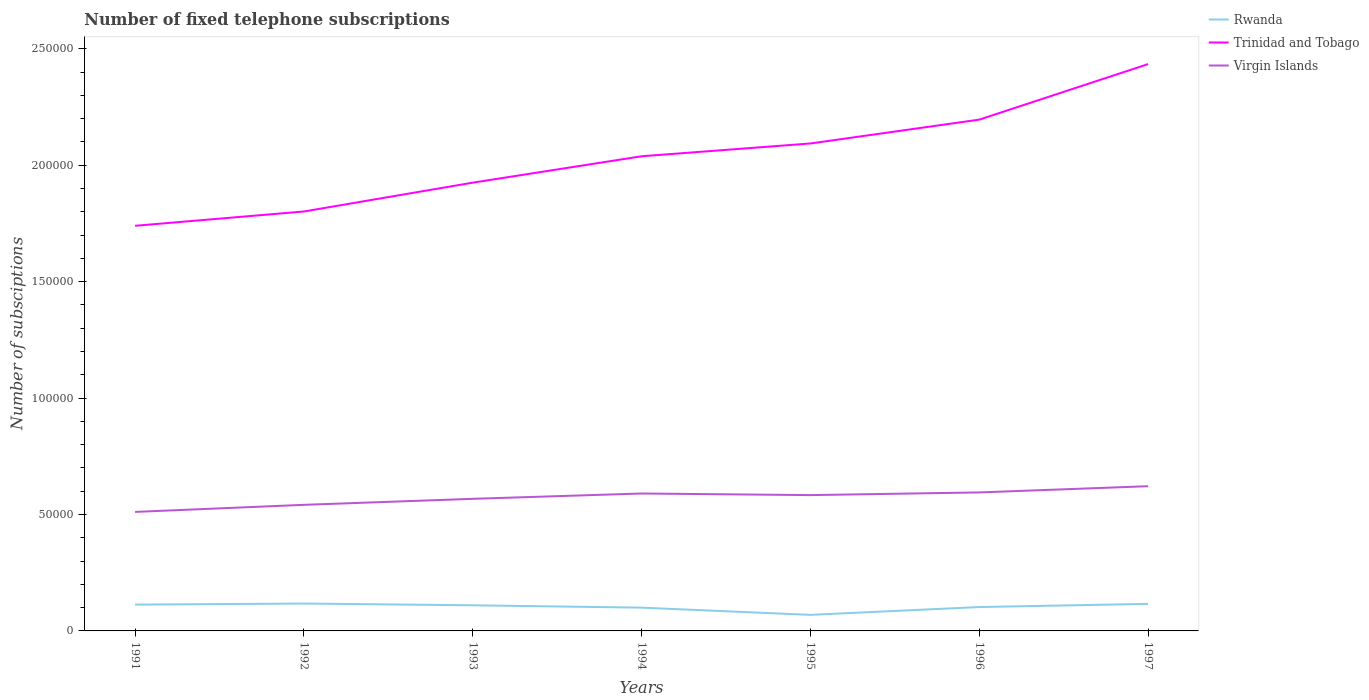How many different coloured lines are there?
Your answer should be very brief. 3. Across all years, what is the maximum number of fixed telephone subscriptions in Rwanda?
Make the answer very short. 6900. In which year was the number of fixed telephone subscriptions in Virgin Islands maximum?
Your answer should be compact. 1991. What is the total number of fixed telephone subscriptions in Virgin Islands in the graph?
Provide a short and direct response. -2291. What is the difference between the highest and the second highest number of fixed telephone subscriptions in Rwanda?
Keep it short and to the point. 4863. How many lines are there?
Your response must be concise. 3. What is the difference between two consecutive major ticks on the Y-axis?
Keep it short and to the point. 5.00e+04. Are the values on the major ticks of Y-axis written in scientific E-notation?
Your response must be concise. No. Where does the legend appear in the graph?
Make the answer very short. Top right. How many legend labels are there?
Provide a short and direct response. 3. What is the title of the graph?
Your response must be concise. Number of fixed telephone subscriptions. Does "France" appear as one of the legend labels in the graph?
Offer a terse response. No. What is the label or title of the Y-axis?
Provide a short and direct response. Number of subsciptions. What is the Number of subsciptions in Rwanda in 1991?
Offer a very short reply. 1.13e+04. What is the Number of subsciptions of Trinidad and Tobago in 1991?
Keep it short and to the point. 1.74e+05. What is the Number of subsciptions of Virgin Islands in 1991?
Ensure brevity in your answer.  5.11e+04. What is the Number of subsciptions in Rwanda in 1992?
Offer a terse response. 1.18e+04. What is the Number of subsciptions of Trinidad and Tobago in 1992?
Offer a very short reply. 1.80e+05. What is the Number of subsciptions in Virgin Islands in 1992?
Provide a short and direct response. 5.41e+04. What is the Number of subsciptions in Rwanda in 1993?
Make the answer very short. 1.10e+04. What is the Number of subsciptions in Trinidad and Tobago in 1993?
Offer a terse response. 1.92e+05. What is the Number of subsciptions of Virgin Islands in 1993?
Provide a succinct answer. 5.67e+04. What is the Number of subsciptions in Rwanda in 1994?
Offer a very short reply. 10000. What is the Number of subsciptions in Trinidad and Tobago in 1994?
Make the answer very short. 2.04e+05. What is the Number of subsciptions of Virgin Islands in 1994?
Make the answer very short. 5.90e+04. What is the Number of subsciptions in Rwanda in 1995?
Keep it short and to the point. 6900. What is the Number of subsciptions in Trinidad and Tobago in 1995?
Your response must be concise. 2.09e+05. What is the Number of subsciptions of Virgin Islands in 1995?
Your response must be concise. 5.83e+04. What is the Number of subsciptions of Rwanda in 1996?
Make the answer very short. 1.03e+04. What is the Number of subsciptions of Trinidad and Tobago in 1996?
Give a very brief answer. 2.20e+05. What is the Number of subsciptions of Virgin Islands in 1996?
Provide a short and direct response. 5.95e+04. What is the Number of subsciptions in Rwanda in 1997?
Your answer should be very brief. 1.16e+04. What is the Number of subsciptions of Trinidad and Tobago in 1997?
Your answer should be compact. 2.43e+05. What is the Number of subsciptions in Virgin Islands in 1997?
Give a very brief answer. 6.21e+04. Across all years, what is the maximum Number of subsciptions in Rwanda?
Offer a terse response. 1.18e+04. Across all years, what is the maximum Number of subsciptions of Trinidad and Tobago?
Make the answer very short. 2.43e+05. Across all years, what is the maximum Number of subsciptions of Virgin Islands?
Keep it short and to the point. 6.21e+04. Across all years, what is the minimum Number of subsciptions of Rwanda?
Offer a terse response. 6900. Across all years, what is the minimum Number of subsciptions of Trinidad and Tobago?
Keep it short and to the point. 1.74e+05. Across all years, what is the minimum Number of subsciptions of Virgin Islands?
Offer a terse response. 5.11e+04. What is the total Number of subsciptions in Rwanda in the graph?
Ensure brevity in your answer.  7.28e+04. What is the total Number of subsciptions in Trinidad and Tobago in the graph?
Offer a terse response. 1.42e+06. What is the total Number of subsciptions of Virgin Islands in the graph?
Offer a terse response. 4.01e+05. What is the difference between the Number of subsciptions of Rwanda in 1991 and that in 1992?
Make the answer very short. -465. What is the difference between the Number of subsciptions of Trinidad and Tobago in 1991 and that in 1992?
Offer a very short reply. -6143. What is the difference between the Number of subsciptions in Virgin Islands in 1991 and that in 1992?
Offer a very short reply. -3038. What is the difference between the Number of subsciptions of Rwanda in 1991 and that in 1993?
Give a very brief answer. 298. What is the difference between the Number of subsciptions of Trinidad and Tobago in 1991 and that in 1993?
Your response must be concise. -1.85e+04. What is the difference between the Number of subsciptions of Virgin Islands in 1991 and that in 1993?
Ensure brevity in your answer.  -5617. What is the difference between the Number of subsciptions in Rwanda in 1991 and that in 1994?
Your answer should be compact. 1298. What is the difference between the Number of subsciptions of Trinidad and Tobago in 1991 and that in 1994?
Give a very brief answer. -2.99e+04. What is the difference between the Number of subsciptions of Virgin Islands in 1991 and that in 1994?
Your answer should be compact. -7908. What is the difference between the Number of subsciptions of Rwanda in 1991 and that in 1995?
Keep it short and to the point. 4398. What is the difference between the Number of subsciptions in Trinidad and Tobago in 1991 and that in 1995?
Offer a terse response. -3.53e+04. What is the difference between the Number of subsciptions in Virgin Islands in 1991 and that in 1995?
Offer a very short reply. -7215. What is the difference between the Number of subsciptions in Rwanda in 1991 and that in 1996?
Provide a succinct answer. 1044. What is the difference between the Number of subsciptions in Trinidad and Tobago in 1991 and that in 1996?
Provide a short and direct response. -4.56e+04. What is the difference between the Number of subsciptions of Virgin Islands in 1991 and that in 1996?
Your response must be concise. -8366. What is the difference between the Number of subsciptions of Rwanda in 1991 and that in 1997?
Your response must be concise. -323. What is the difference between the Number of subsciptions of Trinidad and Tobago in 1991 and that in 1997?
Your answer should be compact. -6.94e+04. What is the difference between the Number of subsciptions of Virgin Islands in 1991 and that in 1997?
Offer a terse response. -1.10e+04. What is the difference between the Number of subsciptions in Rwanda in 1992 and that in 1993?
Provide a succinct answer. 763. What is the difference between the Number of subsciptions of Trinidad and Tobago in 1992 and that in 1993?
Keep it short and to the point. -1.24e+04. What is the difference between the Number of subsciptions of Virgin Islands in 1992 and that in 1993?
Your answer should be compact. -2579. What is the difference between the Number of subsciptions of Rwanda in 1992 and that in 1994?
Provide a short and direct response. 1763. What is the difference between the Number of subsciptions in Trinidad and Tobago in 1992 and that in 1994?
Provide a succinct answer. -2.37e+04. What is the difference between the Number of subsciptions in Virgin Islands in 1992 and that in 1994?
Your answer should be very brief. -4870. What is the difference between the Number of subsciptions of Rwanda in 1992 and that in 1995?
Your response must be concise. 4863. What is the difference between the Number of subsciptions of Trinidad and Tobago in 1992 and that in 1995?
Make the answer very short. -2.92e+04. What is the difference between the Number of subsciptions of Virgin Islands in 1992 and that in 1995?
Give a very brief answer. -4177. What is the difference between the Number of subsciptions of Rwanda in 1992 and that in 1996?
Provide a succinct answer. 1509. What is the difference between the Number of subsciptions in Trinidad and Tobago in 1992 and that in 1996?
Your answer should be very brief. -3.94e+04. What is the difference between the Number of subsciptions in Virgin Islands in 1992 and that in 1996?
Your answer should be very brief. -5328. What is the difference between the Number of subsciptions of Rwanda in 1992 and that in 1997?
Ensure brevity in your answer.  142. What is the difference between the Number of subsciptions in Trinidad and Tobago in 1992 and that in 1997?
Your answer should be compact. -6.33e+04. What is the difference between the Number of subsciptions of Virgin Islands in 1992 and that in 1997?
Make the answer very short. -7998. What is the difference between the Number of subsciptions of Rwanda in 1993 and that in 1994?
Provide a succinct answer. 1000. What is the difference between the Number of subsciptions in Trinidad and Tobago in 1993 and that in 1994?
Give a very brief answer. -1.13e+04. What is the difference between the Number of subsciptions in Virgin Islands in 1993 and that in 1994?
Offer a very short reply. -2291. What is the difference between the Number of subsciptions of Rwanda in 1993 and that in 1995?
Your answer should be compact. 4100. What is the difference between the Number of subsciptions of Trinidad and Tobago in 1993 and that in 1995?
Offer a very short reply. -1.68e+04. What is the difference between the Number of subsciptions of Virgin Islands in 1993 and that in 1995?
Provide a succinct answer. -1598. What is the difference between the Number of subsciptions in Rwanda in 1993 and that in 1996?
Provide a succinct answer. 746. What is the difference between the Number of subsciptions in Trinidad and Tobago in 1993 and that in 1996?
Your response must be concise. -2.71e+04. What is the difference between the Number of subsciptions in Virgin Islands in 1993 and that in 1996?
Keep it short and to the point. -2749. What is the difference between the Number of subsciptions of Rwanda in 1993 and that in 1997?
Your answer should be compact. -621. What is the difference between the Number of subsciptions of Trinidad and Tobago in 1993 and that in 1997?
Make the answer very short. -5.09e+04. What is the difference between the Number of subsciptions in Virgin Islands in 1993 and that in 1997?
Provide a short and direct response. -5419. What is the difference between the Number of subsciptions in Rwanda in 1994 and that in 1995?
Ensure brevity in your answer.  3100. What is the difference between the Number of subsciptions of Trinidad and Tobago in 1994 and that in 1995?
Offer a terse response. -5493. What is the difference between the Number of subsciptions of Virgin Islands in 1994 and that in 1995?
Offer a terse response. 693. What is the difference between the Number of subsciptions in Rwanda in 1994 and that in 1996?
Your answer should be compact. -254. What is the difference between the Number of subsciptions of Trinidad and Tobago in 1994 and that in 1996?
Give a very brief answer. -1.57e+04. What is the difference between the Number of subsciptions of Virgin Islands in 1994 and that in 1996?
Offer a terse response. -458. What is the difference between the Number of subsciptions in Rwanda in 1994 and that in 1997?
Give a very brief answer. -1621. What is the difference between the Number of subsciptions of Trinidad and Tobago in 1994 and that in 1997?
Ensure brevity in your answer.  -3.96e+04. What is the difference between the Number of subsciptions of Virgin Islands in 1994 and that in 1997?
Ensure brevity in your answer.  -3128. What is the difference between the Number of subsciptions in Rwanda in 1995 and that in 1996?
Keep it short and to the point. -3354. What is the difference between the Number of subsciptions in Trinidad and Tobago in 1995 and that in 1996?
Give a very brief answer. -1.02e+04. What is the difference between the Number of subsciptions of Virgin Islands in 1995 and that in 1996?
Offer a terse response. -1151. What is the difference between the Number of subsciptions of Rwanda in 1995 and that in 1997?
Offer a very short reply. -4721. What is the difference between the Number of subsciptions in Trinidad and Tobago in 1995 and that in 1997?
Your answer should be compact. -3.41e+04. What is the difference between the Number of subsciptions of Virgin Islands in 1995 and that in 1997?
Your answer should be very brief. -3821. What is the difference between the Number of subsciptions in Rwanda in 1996 and that in 1997?
Your answer should be very brief. -1367. What is the difference between the Number of subsciptions in Trinidad and Tobago in 1996 and that in 1997?
Make the answer very short. -2.38e+04. What is the difference between the Number of subsciptions of Virgin Islands in 1996 and that in 1997?
Offer a very short reply. -2670. What is the difference between the Number of subsciptions of Rwanda in 1991 and the Number of subsciptions of Trinidad and Tobago in 1992?
Provide a succinct answer. -1.69e+05. What is the difference between the Number of subsciptions in Rwanda in 1991 and the Number of subsciptions in Virgin Islands in 1992?
Keep it short and to the point. -4.28e+04. What is the difference between the Number of subsciptions of Trinidad and Tobago in 1991 and the Number of subsciptions of Virgin Islands in 1992?
Keep it short and to the point. 1.20e+05. What is the difference between the Number of subsciptions in Rwanda in 1991 and the Number of subsciptions in Trinidad and Tobago in 1993?
Provide a short and direct response. -1.81e+05. What is the difference between the Number of subsciptions in Rwanda in 1991 and the Number of subsciptions in Virgin Islands in 1993?
Give a very brief answer. -4.54e+04. What is the difference between the Number of subsciptions in Trinidad and Tobago in 1991 and the Number of subsciptions in Virgin Islands in 1993?
Provide a short and direct response. 1.17e+05. What is the difference between the Number of subsciptions of Rwanda in 1991 and the Number of subsciptions of Trinidad and Tobago in 1994?
Ensure brevity in your answer.  -1.93e+05. What is the difference between the Number of subsciptions of Rwanda in 1991 and the Number of subsciptions of Virgin Islands in 1994?
Provide a short and direct response. -4.77e+04. What is the difference between the Number of subsciptions in Trinidad and Tobago in 1991 and the Number of subsciptions in Virgin Islands in 1994?
Offer a very short reply. 1.15e+05. What is the difference between the Number of subsciptions in Rwanda in 1991 and the Number of subsciptions in Trinidad and Tobago in 1995?
Your answer should be very brief. -1.98e+05. What is the difference between the Number of subsciptions in Rwanda in 1991 and the Number of subsciptions in Virgin Islands in 1995?
Give a very brief answer. -4.70e+04. What is the difference between the Number of subsciptions of Trinidad and Tobago in 1991 and the Number of subsciptions of Virgin Islands in 1995?
Provide a succinct answer. 1.16e+05. What is the difference between the Number of subsciptions in Rwanda in 1991 and the Number of subsciptions in Trinidad and Tobago in 1996?
Your answer should be compact. -2.08e+05. What is the difference between the Number of subsciptions in Rwanda in 1991 and the Number of subsciptions in Virgin Islands in 1996?
Your answer should be compact. -4.82e+04. What is the difference between the Number of subsciptions of Trinidad and Tobago in 1991 and the Number of subsciptions of Virgin Islands in 1996?
Keep it short and to the point. 1.14e+05. What is the difference between the Number of subsciptions in Rwanda in 1991 and the Number of subsciptions in Trinidad and Tobago in 1997?
Ensure brevity in your answer.  -2.32e+05. What is the difference between the Number of subsciptions of Rwanda in 1991 and the Number of subsciptions of Virgin Islands in 1997?
Provide a succinct answer. -5.08e+04. What is the difference between the Number of subsciptions of Trinidad and Tobago in 1991 and the Number of subsciptions of Virgin Islands in 1997?
Your answer should be very brief. 1.12e+05. What is the difference between the Number of subsciptions in Rwanda in 1992 and the Number of subsciptions in Trinidad and Tobago in 1993?
Make the answer very short. -1.81e+05. What is the difference between the Number of subsciptions of Rwanda in 1992 and the Number of subsciptions of Virgin Islands in 1993?
Provide a short and direct response. -4.50e+04. What is the difference between the Number of subsciptions of Trinidad and Tobago in 1992 and the Number of subsciptions of Virgin Islands in 1993?
Provide a short and direct response. 1.23e+05. What is the difference between the Number of subsciptions of Rwanda in 1992 and the Number of subsciptions of Trinidad and Tobago in 1994?
Keep it short and to the point. -1.92e+05. What is the difference between the Number of subsciptions in Rwanda in 1992 and the Number of subsciptions in Virgin Islands in 1994?
Offer a terse response. -4.72e+04. What is the difference between the Number of subsciptions in Trinidad and Tobago in 1992 and the Number of subsciptions in Virgin Islands in 1994?
Your answer should be compact. 1.21e+05. What is the difference between the Number of subsciptions in Rwanda in 1992 and the Number of subsciptions in Trinidad and Tobago in 1995?
Give a very brief answer. -1.98e+05. What is the difference between the Number of subsciptions of Rwanda in 1992 and the Number of subsciptions of Virgin Islands in 1995?
Offer a terse response. -4.66e+04. What is the difference between the Number of subsciptions in Trinidad and Tobago in 1992 and the Number of subsciptions in Virgin Islands in 1995?
Offer a terse response. 1.22e+05. What is the difference between the Number of subsciptions in Rwanda in 1992 and the Number of subsciptions in Trinidad and Tobago in 1996?
Provide a short and direct response. -2.08e+05. What is the difference between the Number of subsciptions of Rwanda in 1992 and the Number of subsciptions of Virgin Islands in 1996?
Offer a very short reply. -4.77e+04. What is the difference between the Number of subsciptions in Trinidad and Tobago in 1992 and the Number of subsciptions in Virgin Islands in 1996?
Ensure brevity in your answer.  1.21e+05. What is the difference between the Number of subsciptions of Rwanda in 1992 and the Number of subsciptions of Trinidad and Tobago in 1997?
Your response must be concise. -2.32e+05. What is the difference between the Number of subsciptions in Rwanda in 1992 and the Number of subsciptions in Virgin Islands in 1997?
Keep it short and to the point. -5.04e+04. What is the difference between the Number of subsciptions in Trinidad and Tobago in 1992 and the Number of subsciptions in Virgin Islands in 1997?
Provide a short and direct response. 1.18e+05. What is the difference between the Number of subsciptions of Rwanda in 1993 and the Number of subsciptions of Trinidad and Tobago in 1994?
Provide a succinct answer. -1.93e+05. What is the difference between the Number of subsciptions in Rwanda in 1993 and the Number of subsciptions in Virgin Islands in 1994?
Offer a very short reply. -4.80e+04. What is the difference between the Number of subsciptions in Trinidad and Tobago in 1993 and the Number of subsciptions in Virgin Islands in 1994?
Ensure brevity in your answer.  1.33e+05. What is the difference between the Number of subsciptions of Rwanda in 1993 and the Number of subsciptions of Trinidad and Tobago in 1995?
Keep it short and to the point. -1.98e+05. What is the difference between the Number of subsciptions of Rwanda in 1993 and the Number of subsciptions of Virgin Islands in 1995?
Your response must be concise. -4.73e+04. What is the difference between the Number of subsciptions in Trinidad and Tobago in 1993 and the Number of subsciptions in Virgin Islands in 1995?
Make the answer very short. 1.34e+05. What is the difference between the Number of subsciptions of Rwanda in 1993 and the Number of subsciptions of Trinidad and Tobago in 1996?
Your answer should be compact. -2.09e+05. What is the difference between the Number of subsciptions of Rwanda in 1993 and the Number of subsciptions of Virgin Islands in 1996?
Provide a succinct answer. -4.85e+04. What is the difference between the Number of subsciptions in Trinidad and Tobago in 1993 and the Number of subsciptions in Virgin Islands in 1996?
Ensure brevity in your answer.  1.33e+05. What is the difference between the Number of subsciptions in Rwanda in 1993 and the Number of subsciptions in Trinidad and Tobago in 1997?
Your answer should be very brief. -2.32e+05. What is the difference between the Number of subsciptions in Rwanda in 1993 and the Number of subsciptions in Virgin Islands in 1997?
Keep it short and to the point. -5.11e+04. What is the difference between the Number of subsciptions in Trinidad and Tobago in 1993 and the Number of subsciptions in Virgin Islands in 1997?
Ensure brevity in your answer.  1.30e+05. What is the difference between the Number of subsciptions in Rwanda in 1994 and the Number of subsciptions in Trinidad and Tobago in 1995?
Offer a very short reply. -1.99e+05. What is the difference between the Number of subsciptions of Rwanda in 1994 and the Number of subsciptions of Virgin Islands in 1995?
Make the answer very short. -4.83e+04. What is the difference between the Number of subsciptions in Trinidad and Tobago in 1994 and the Number of subsciptions in Virgin Islands in 1995?
Provide a short and direct response. 1.45e+05. What is the difference between the Number of subsciptions of Rwanda in 1994 and the Number of subsciptions of Trinidad and Tobago in 1996?
Your response must be concise. -2.10e+05. What is the difference between the Number of subsciptions of Rwanda in 1994 and the Number of subsciptions of Virgin Islands in 1996?
Offer a terse response. -4.95e+04. What is the difference between the Number of subsciptions of Trinidad and Tobago in 1994 and the Number of subsciptions of Virgin Islands in 1996?
Offer a very short reply. 1.44e+05. What is the difference between the Number of subsciptions in Rwanda in 1994 and the Number of subsciptions in Trinidad and Tobago in 1997?
Your answer should be compact. -2.33e+05. What is the difference between the Number of subsciptions in Rwanda in 1994 and the Number of subsciptions in Virgin Islands in 1997?
Make the answer very short. -5.21e+04. What is the difference between the Number of subsciptions of Trinidad and Tobago in 1994 and the Number of subsciptions of Virgin Islands in 1997?
Your response must be concise. 1.42e+05. What is the difference between the Number of subsciptions of Rwanda in 1995 and the Number of subsciptions of Trinidad and Tobago in 1996?
Keep it short and to the point. -2.13e+05. What is the difference between the Number of subsciptions of Rwanda in 1995 and the Number of subsciptions of Virgin Islands in 1996?
Ensure brevity in your answer.  -5.26e+04. What is the difference between the Number of subsciptions of Trinidad and Tobago in 1995 and the Number of subsciptions of Virgin Islands in 1996?
Give a very brief answer. 1.50e+05. What is the difference between the Number of subsciptions in Rwanda in 1995 and the Number of subsciptions in Trinidad and Tobago in 1997?
Offer a very short reply. -2.36e+05. What is the difference between the Number of subsciptions in Rwanda in 1995 and the Number of subsciptions in Virgin Islands in 1997?
Ensure brevity in your answer.  -5.52e+04. What is the difference between the Number of subsciptions of Trinidad and Tobago in 1995 and the Number of subsciptions of Virgin Islands in 1997?
Your answer should be very brief. 1.47e+05. What is the difference between the Number of subsciptions in Rwanda in 1996 and the Number of subsciptions in Trinidad and Tobago in 1997?
Your answer should be very brief. -2.33e+05. What is the difference between the Number of subsciptions of Rwanda in 1996 and the Number of subsciptions of Virgin Islands in 1997?
Make the answer very short. -5.19e+04. What is the difference between the Number of subsciptions in Trinidad and Tobago in 1996 and the Number of subsciptions in Virgin Islands in 1997?
Provide a short and direct response. 1.57e+05. What is the average Number of subsciptions in Rwanda per year?
Offer a terse response. 1.04e+04. What is the average Number of subsciptions of Trinidad and Tobago per year?
Your answer should be very brief. 2.03e+05. What is the average Number of subsciptions of Virgin Islands per year?
Your answer should be compact. 5.73e+04. In the year 1991, what is the difference between the Number of subsciptions in Rwanda and Number of subsciptions in Trinidad and Tobago?
Make the answer very short. -1.63e+05. In the year 1991, what is the difference between the Number of subsciptions of Rwanda and Number of subsciptions of Virgin Islands?
Provide a succinct answer. -3.98e+04. In the year 1991, what is the difference between the Number of subsciptions of Trinidad and Tobago and Number of subsciptions of Virgin Islands?
Your response must be concise. 1.23e+05. In the year 1992, what is the difference between the Number of subsciptions in Rwanda and Number of subsciptions in Trinidad and Tobago?
Offer a terse response. -1.68e+05. In the year 1992, what is the difference between the Number of subsciptions in Rwanda and Number of subsciptions in Virgin Islands?
Offer a very short reply. -4.24e+04. In the year 1992, what is the difference between the Number of subsciptions in Trinidad and Tobago and Number of subsciptions in Virgin Islands?
Your answer should be compact. 1.26e+05. In the year 1993, what is the difference between the Number of subsciptions of Rwanda and Number of subsciptions of Trinidad and Tobago?
Give a very brief answer. -1.81e+05. In the year 1993, what is the difference between the Number of subsciptions of Rwanda and Number of subsciptions of Virgin Islands?
Provide a succinct answer. -4.57e+04. In the year 1993, what is the difference between the Number of subsciptions in Trinidad and Tobago and Number of subsciptions in Virgin Islands?
Keep it short and to the point. 1.36e+05. In the year 1994, what is the difference between the Number of subsciptions in Rwanda and Number of subsciptions in Trinidad and Tobago?
Make the answer very short. -1.94e+05. In the year 1994, what is the difference between the Number of subsciptions of Rwanda and Number of subsciptions of Virgin Islands?
Offer a very short reply. -4.90e+04. In the year 1994, what is the difference between the Number of subsciptions in Trinidad and Tobago and Number of subsciptions in Virgin Islands?
Provide a short and direct response. 1.45e+05. In the year 1995, what is the difference between the Number of subsciptions in Rwanda and Number of subsciptions in Trinidad and Tobago?
Offer a terse response. -2.02e+05. In the year 1995, what is the difference between the Number of subsciptions in Rwanda and Number of subsciptions in Virgin Islands?
Provide a short and direct response. -5.14e+04. In the year 1995, what is the difference between the Number of subsciptions in Trinidad and Tobago and Number of subsciptions in Virgin Islands?
Your answer should be very brief. 1.51e+05. In the year 1996, what is the difference between the Number of subsciptions of Rwanda and Number of subsciptions of Trinidad and Tobago?
Provide a short and direct response. -2.09e+05. In the year 1996, what is the difference between the Number of subsciptions of Rwanda and Number of subsciptions of Virgin Islands?
Offer a terse response. -4.92e+04. In the year 1996, what is the difference between the Number of subsciptions of Trinidad and Tobago and Number of subsciptions of Virgin Islands?
Provide a succinct answer. 1.60e+05. In the year 1997, what is the difference between the Number of subsciptions of Rwanda and Number of subsciptions of Trinidad and Tobago?
Keep it short and to the point. -2.32e+05. In the year 1997, what is the difference between the Number of subsciptions of Rwanda and Number of subsciptions of Virgin Islands?
Offer a very short reply. -5.05e+04. In the year 1997, what is the difference between the Number of subsciptions of Trinidad and Tobago and Number of subsciptions of Virgin Islands?
Provide a succinct answer. 1.81e+05. What is the ratio of the Number of subsciptions of Rwanda in 1991 to that in 1992?
Ensure brevity in your answer.  0.96. What is the ratio of the Number of subsciptions in Trinidad and Tobago in 1991 to that in 1992?
Provide a short and direct response. 0.97. What is the ratio of the Number of subsciptions of Virgin Islands in 1991 to that in 1992?
Offer a very short reply. 0.94. What is the ratio of the Number of subsciptions of Rwanda in 1991 to that in 1993?
Give a very brief answer. 1.03. What is the ratio of the Number of subsciptions in Trinidad and Tobago in 1991 to that in 1993?
Your answer should be very brief. 0.9. What is the ratio of the Number of subsciptions of Virgin Islands in 1991 to that in 1993?
Provide a succinct answer. 0.9. What is the ratio of the Number of subsciptions of Rwanda in 1991 to that in 1994?
Provide a short and direct response. 1.13. What is the ratio of the Number of subsciptions in Trinidad and Tobago in 1991 to that in 1994?
Keep it short and to the point. 0.85. What is the ratio of the Number of subsciptions in Virgin Islands in 1991 to that in 1994?
Your answer should be compact. 0.87. What is the ratio of the Number of subsciptions in Rwanda in 1991 to that in 1995?
Provide a succinct answer. 1.64. What is the ratio of the Number of subsciptions in Trinidad and Tobago in 1991 to that in 1995?
Your response must be concise. 0.83. What is the ratio of the Number of subsciptions of Virgin Islands in 1991 to that in 1995?
Your response must be concise. 0.88. What is the ratio of the Number of subsciptions in Rwanda in 1991 to that in 1996?
Keep it short and to the point. 1.1. What is the ratio of the Number of subsciptions in Trinidad and Tobago in 1991 to that in 1996?
Your answer should be compact. 0.79. What is the ratio of the Number of subsciptions in Virgin Islands in 1991 to that in 1996?
Your response must be concise. 0.86. What is the ratio of the Number of subsciptions of Rwanda in 1991 to that in 1997?
Your answer should be compact. 0.97. What is the ratio of the Number of subsciptions of Trinidad and Tobago in 1991 to that in 1997?
Provide a short and direct response. 0.71. What is the ratio of the Number of subsciptions of Virgin Islands in 1991 to that in 1997?
Provide a short and direct response. 0.82. What is the ratio of the Number of subsciptions in Rwanda in 1992 to that in 1993?
Your answer should be very brief. 1.07. What is the ratio of the Number of subsciptions of Trinidad and Tobago in 1992 to that in 1993?
Offer a terse response. 0.94. What is the ratio of the Number of subsciptions of Virgin Islands in 1992 to that in 1993?
Keep it short and to the point. 0.95. What is the ratio of the Number of subsciptions of Rwanda in 1992 to that in 1994?
Make the answer very short. 1.18. What is the ratio of the Number of subsciptions of Trinidad and Tobago in 1992 to that in 1994?
Provide a succinct answer. 0.88. What is the ratio of the Number of subsciptions in Virgin Islands in 1992 to that in 1994?
Offer a very short reply. 0.92. What is the ratio of the Number of subsciptions of Rwanda in 1992 to that in 1995?
Ensure brevity in your answer.  1.7. What is the ratio of the Number of subsciptions in Trinidad and Tobago in 1992 to that in 1995?
Your answer should be compact. 0.86. What is the ratio of the Number of subsciptions of Virgin Islands in 1992 to that in 1995?
Your response must be concise. 0.93. What is the ratio of the Number of subsciptions of Rwanda in 1992 to that in 1996?
Offer a terse response. 1.15. What is the ratio of the Number of subsciptions of Trinidad and Tobago in 1992 to that in 1996?
Give a very brief answer. 0.82. What is the ratio of the Number of subsciptions in Virgin Islands in 1992 to that in 1996?
Your answer should be very brief. 0.91. What is the ratio of the Number of subsciptions of Rwanda in 1992 to that in 1997?
Provide a short and direct response. 1.01. What is the ratio of the Number of subsciptions in Trinidad and Tobago in 1992 to that in 1997?
Your answer should be very brief. 0.74. What is the ratio of the Number of subsciptions in Virgin Islands in 1992 to that in 1997?
Keep it short and to the point. 0.87. What is the ratio of the Number of subsciptions of Virgin Islands in 1993 to that in 1994?
Give a very brief answer. 0.96. What is the ratio of the Number of subsciptions of Rwanda in 1993 to that in 1995?
Your answer should be compact. 1.59. What is the ratio of the Number of subsciptions in Trinidad and Tobago in 1993 to that in 1995?
Offer a very short reply. 0.92. What is the ratio of the Number of subsciptions in Virgin Islands in 1993 to that in 1995?
Make the answer very short. 0.97. What is the ratio of the Number of subsciptions of Rwanda in 1993 to that in 1996?
Offer a very short reply. 1.07. What is the ratio of the Number of subsciptions of Trinidad and Tobago in 1993 to that in 1996?
Give a very brief answer. 0.88. What is the ratio of the Number of subsciptions in Virgin Islands in 1993 to that in 1996?
Offer a terse response. 0.95. What is the ratio of the Number of subsciptions of Rwanda in 1993 to that in 1997?
Make the answer very short. 0.95. What is the ratio of the Number of subsciptions of Trinidad and Tobago in 1993 to that in 1997?
Your answer should be compact. 0.79. What is the ratio of the Number of subsciptions of Virgin Islands in 1993 to that in 1997?
Your answer should be compact. 0.91. What is the ratio of the Number of subsciptions in Rwanda in 1994 to that in 1995?
Your response must be concise. 1.45. What is the ratio of the Number of subsciptions of Trinidad and Tobago in 1994 to that in 1995?
Your answer should be compact. 0.97. What is the ratio of the Number of subsciptions of Virgin Islands in 1994 to that in 1995?
Your answer should be compact. 1.01. What is the ratio of the Number of subsciptions in Rwanda in 1994 to that in 1996?
Ensure brevity in your answer.  0.98. What is the ratio of the Number of subsciptions in Trinidad and Tobago in 1994 to that in 1996?
Keep it short and to the point. 0.93. What is the ratio of the Number of subsciptions of Rwanda in 1994 to that in 1997?
Your answer should be very brief. 0.86. What is the ratio of the Number of subsciptions in Trinidad and Tobago in 1994 to that in 1997?
Your answer should be very brief. 0.84. What is the ratio of the Number of subsciptions of Virgin Islands in 1994 to that in 1997?
Make the answer very short. 0.95. What is the ratio of the Number of subsciptions of Rwanda in 1995 to that in 1996?
Your response must be concise. 0.67. What is the ratio of the Number of subsciptions of Trinidad and Tobago in 1995 to that in 1996?
Offer a terse response. 0.95. What is the ratio of the Number of subsciptions of Virgin Islands in 1995 to that in 1996?
Provide a succinct answer. 0.98. What is the ratio of the Number of subsciptions in Rwanda in 1995 to that in 1997?
Your response must be concise. 0.59. What is the ratio of the Number of subsciptions in Trinidad and Tobago in 1995 to that in 1997?
Make the answer very short. 0.86. What is the ratio of the Number of subsciptions of Virgin Islands in 1995 to that in 1997?
Provide a short and direct response. 0.94. What is the ratio of the Number of subsciptions in Rwanda in 1996 to that in 1997?
Ensure brevity in your answer.  0.88. What is the ratio of the Number of subsciptions in Trinidad and Tobago in 1996 to that in 1997?
Make the answer very short. 0.9. What is the ratio of the Number of subsciptions of Virgin Islands in 1996 to that in 1997?
Offer a terse response. 0.96. What is the difference between the highest and the second highest Number of subsciptions in Rwanda?
Your response must be concise. 142. What is the difference between the highest and the second highest Number of subsciptions in Trinidad and Tobago?
Your response must be concise. 2.38e+04. What is the difference between the highest and the second highest Number of subsciptions of Virgin Islands?
Offer a terse response. 2670. What is the difference between the highest and the lowest Number of subsciptions in Rwanda?
Your response must be concise. 4863. What is the difference between the highest and the lowest Number of subsciptions of Trinidad and Tobago?
Your answer should be very brief. 6.94e+04. What is the difference between the highest and the lowest Number of subsciptions of Virgin Islands?
Ensure brevity in your answer.  1.10e+04. 